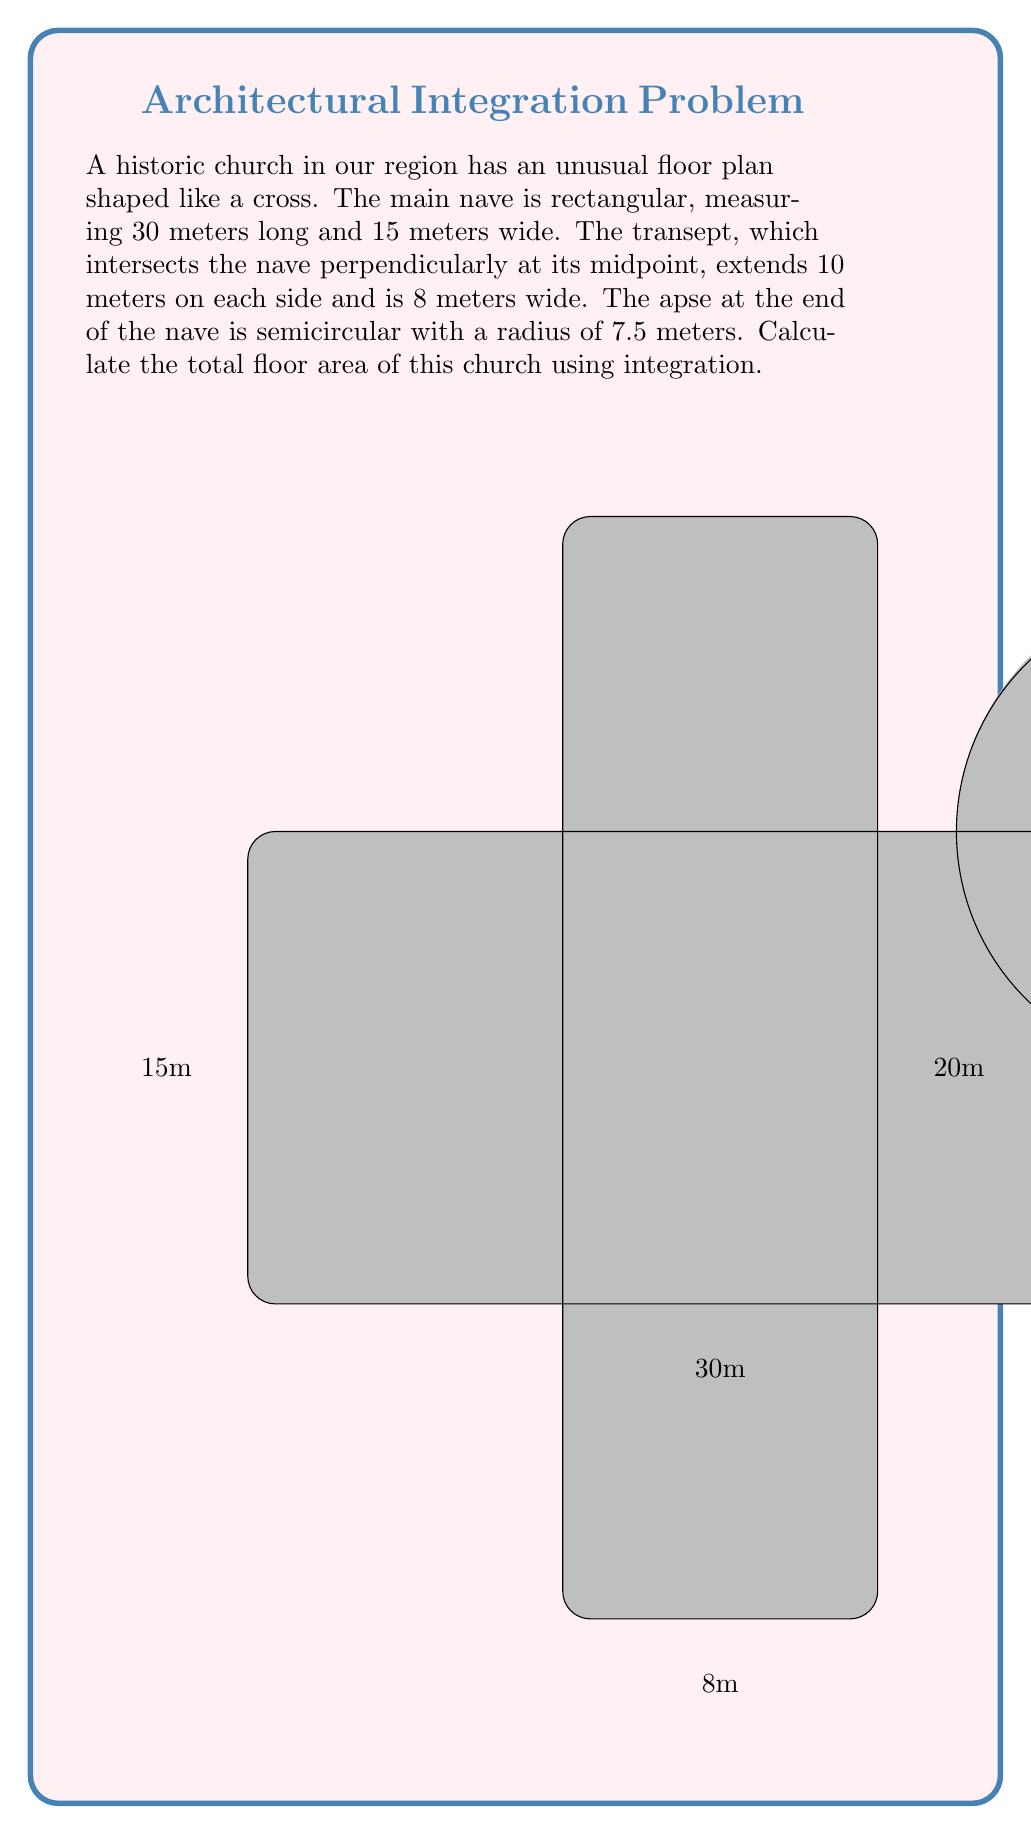Can you solve this math problem? To calculate the total floor area, we'll break the church into three parts and use integration where necessary:

1. Main nave (rectangular):
   Area = length × width = 30m × 15m = 450 m²

2. Transept (rectangular):
   Area = length × width = 20m × 8m = 160 m²

3. Apse (semicircular):
   We'll use integration to calculate this area.

   The semicircle can be described by the equation:
   $$y = \sqrt{r^2 - (x-30)^2}$$
   where r = 7.5m and the center is at (30, 15).

   The area is given by the integral:
   $$A = \int_{22.5}^{30} \sqrt{7.5^2 - (x-30)^2} dx$$

   This integral can be solved using trigonometric substitution:
   Let $x - 30 = 7.5\sin\theta$, then $dx = 7.5\cos\theta d\theta$

   When $x = 22.5$, $\theta = -\frac{\pi}{2}$
   When $x = 30$, $\theta = 0$

   Substituting:
   $$A = \int_{-\frac{\pi}{2}}^{0} 7.5\sqrt{1 - \sin^2\theta} \cdot 7.5\cos\theta d\theta$$
   $$= 56.25 \int_{-\frac{\pi}{2}}^{0} \cos^2\theta d\theta$$
   $$= 56.25 \left[\frac{\theta}{2} + \frac{\sin(2\theta)}{4}\right]_{-\frac{\pi}{2}}^{0}$$
   $$= 56.25 \cdot \frac{\pi}{4} \approx 44.18 \text{ m}^2$$

Total area:
450 m² + 160 m² + 44.18 m² = 654.18 m²
Answer: The total floor area of the church is approximately 654.18 square meters. 